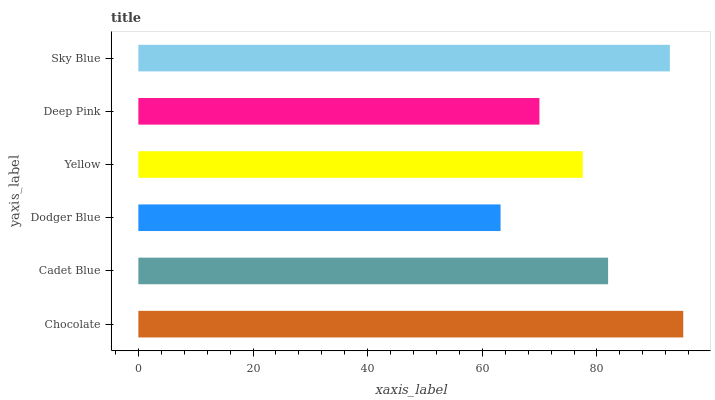Is Dodger Blue the minimum?
Answer yes or no. Yes. Is Chocolate the maximum?
Answer yes or no. Yes. Is Cadet Blue the minimum?
Answer yes or no. No. Is Cadet Blue the maximum?
Answer yes or no. No. Is Chocolate greater than Cadet Blue?
Answer yes or no. Yes. Is Cadet Blue less than Chocolate?
Answer yes or no. Yes. Is Cadet Blue greater than Chocolate?
Answer yes or no. No. Is Chocolate less than Cadet Blue?
Answer yes or no. No. Is Cadet Blue the high median?
Answer yes or no. Yes. Is Yellow the low median?
Answer yes or no. Yes. Is Deep Pink the high median?
Answer yes or no. No. Is Cadet Blue the low median?
Answer yes or no. No. 